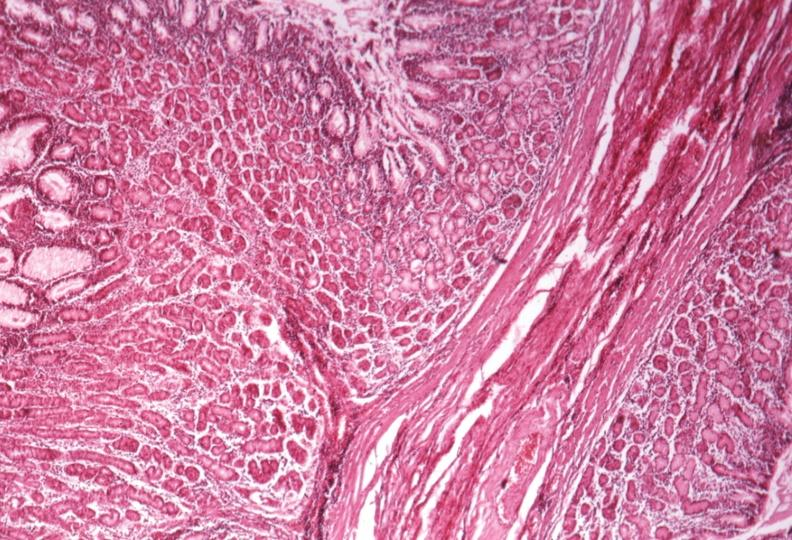s hypertrophic gastritis present?
Answer the question using a single word or phrase. Yes 